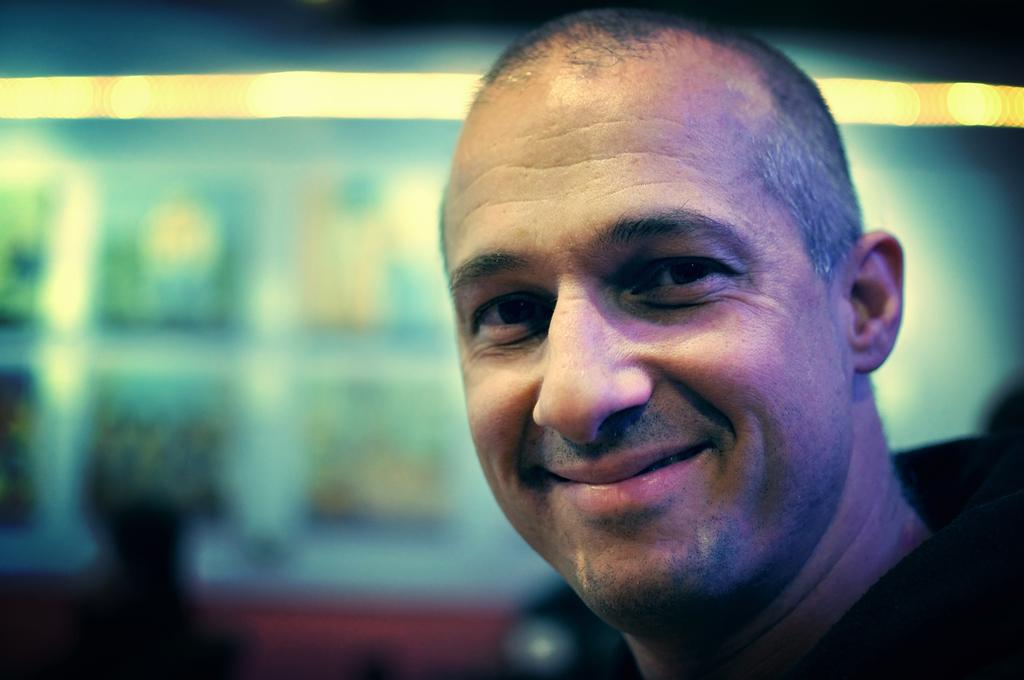Who is in the image? There is a man in the image. What is the man wearing? The man is wearing a black dress. What is the man doing in the image? The man is laughing. What can be seen in the background of the image? There are lights in the background of the image. How would you describe the background of the image? The background of the image is blurred. What type of knowledge can be gained from the playground in the image? There is no playground present in the image, so no knowledge can be gained from it. 